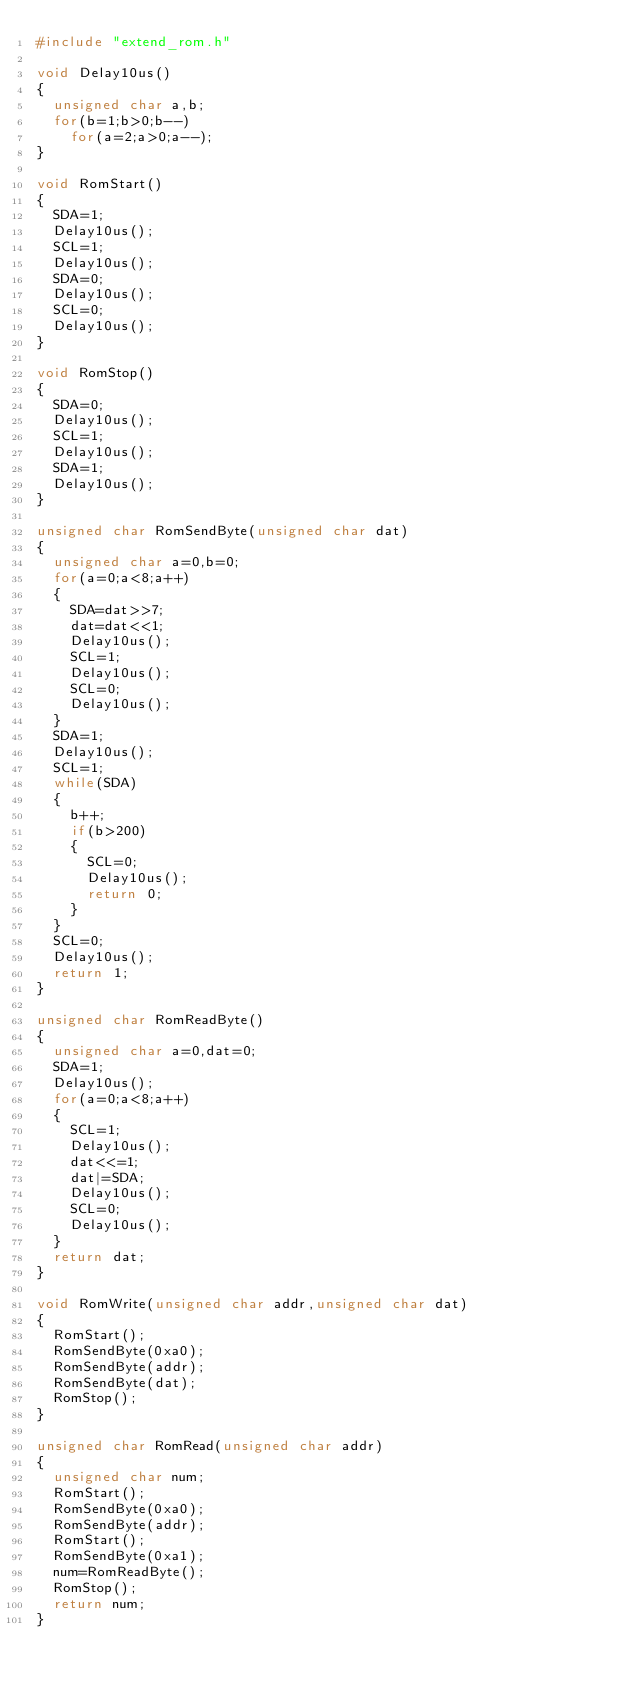<code> <loc_0><loc_0><loc_500><loc_500><_C_>#include "extend_rom.h"

void Delay10us()
{
	unsigned char a,b;
	for(b=1;b>0;b--)
		for(a=2;a>0;a--);
}

void RomStart()
{
	SDA=1;
	Delay10us();
	SCL=1;
	Delay10us();
	SDA=0;
	Delay10us();
	SCL=0;
	Delay10us();
}

void RomStop()
{
	SDA=0;
	Delay10us();
	SCL=1;
	Delay10us();
	SDA=1;
	Delay10us();
}

unsigned char RomSendByte(unsigned char dat)
{
	unsigned char a=0,b=0;
	for(a=0;a<8;a++)
	{
		SDA=dat>>7;
		dat=dat<<1;
		Delay10us();
		SCL=1;
		Delay10us();
		SCL=0;
		Delay10us();
	}
	SDA=1;
	Delay10us();
	SCL=1;
	while(SDA)
	{
		b++;
		if(b>200)
		{
			SCL=0;
			Delay10us();
			return 0;
		}
	}
	SCL=0;
	Delay10us();
	return 1;
}

unsigned char RomReadByte()
{
	unsigned char a=0,dat=0;
	SDA=1;
	Delay10us();
	for(a=0;a<8;a++)
	{
		SCL=1;
		Delay10us();
		dat<<=1;
		dat|=SDA;
		Delay10us();
		SCL=0;
		Delay10us();
	}
	return dat;
}

void RomWrite(unsigned char addr,unsigned char dat)
{
	RomStart();
	RomSendByte(0xa0);
	RomSendByte(addr);
	RomSendByte(dat);
	RomStop();
}

unsigned char RomRead(unsigned char addr)
{
	unsigned char num;
	RomStart();
	RomSendByte(0xa0);
	RomSendByte(addr);
	RomStart();
	RomSendByte(0xa1);
	num=RomReadByte();
	RomStop();
	return num;
}</code> 